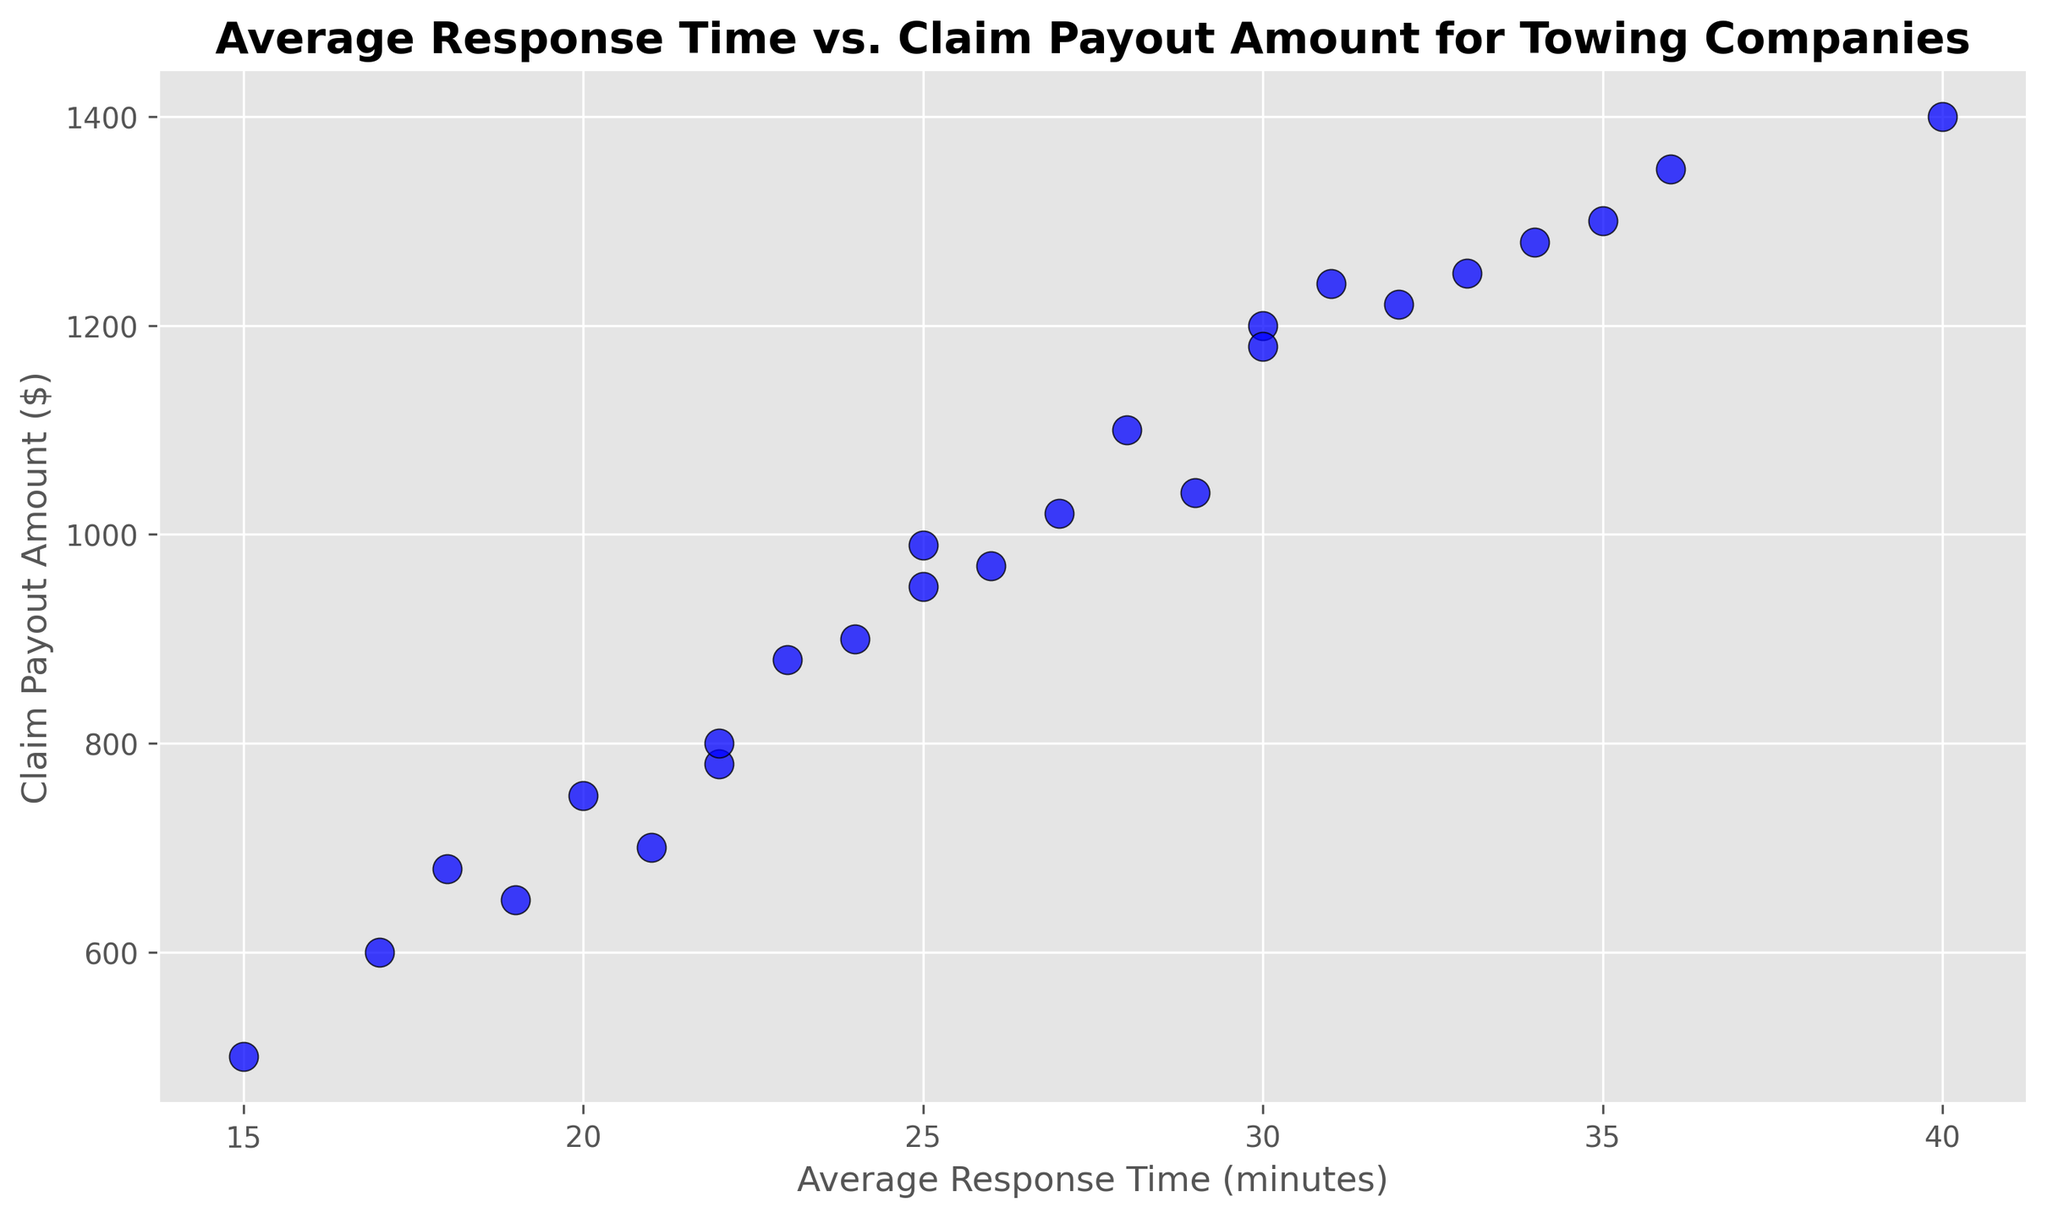What is the highest claim payout amount and at what average response time does it occur? By observing the scatter plot, locate the point with the highest y-value, which represents the largest claim payout amount. Check the corresponding x-value to find the average response time.
Answer: $1400 at 40 minutes Is there any visible trend between average response time and claim payout amount? Look at the overall distribution and pattern of the points. Determine whether the points form a specific trend, such as an increasing or decreasing pattern.
Answer: No clear trend At what average response time do we see the lowest claim payout amount? Identify the point with the lowest y-value on the scatter plot, which represents the smallest claim payout amount. Note the corresponding x-value to find the average response time.
Answer: 15 minutes Which data point has a claim payout amount close to $1000 and what is its average response time? Locate points near the y-value of 1000 dollars. Identify the exact x-value from these points to get the average response time.
Answer: $990 at 25 minutes Compare the claim payout amount at an average response time of 17 minutes and 35 minutes. Which one is higher? Find the points where x = 17 and x = 35. Compare the y-values of these points to see which is higher.
Answer: $600 at 17 minutes vs. $1300 at 35 minutes. $1300 at 35 minutes is higher What is the median claim payout amount in the scatter plot? Arrange all the claim payout amounts in ascending order. The median is the middle value if the total number of points is odd, or the average of the two middle values if even.
Answer: $950 Among the average response times of 18 minutes and 24 minutes, which one has the lower claim payout amount, and what are the actual amounts? Find points where x = 18 and x = 24. Compare their y-values to see which is lower and state the values.
Answer: $680 at 18 minutes vs. $900 at 24 minutes. $680 at 18 minutes is lower Do any two points on the scatter plot have identical claim payout amounts with different average response times? Check if there are any points where the y-values are the same but x-values are different.
Answer: Yes, $800 at 22 and 21 minutes What is the average claim payout amount for response times greater than 30 minutes? Identify all points where x > 30. Sum their y-values and divide by the number of these points to find the average.
Answer: (1400 + 1300 + 1350 + 1250 + 1220 + 1240 + 1280) / 7 = $1291.43 How many claim payout amounts are above $1000? Count the number of points where y-values are greater than $1000.
Answer: 11 